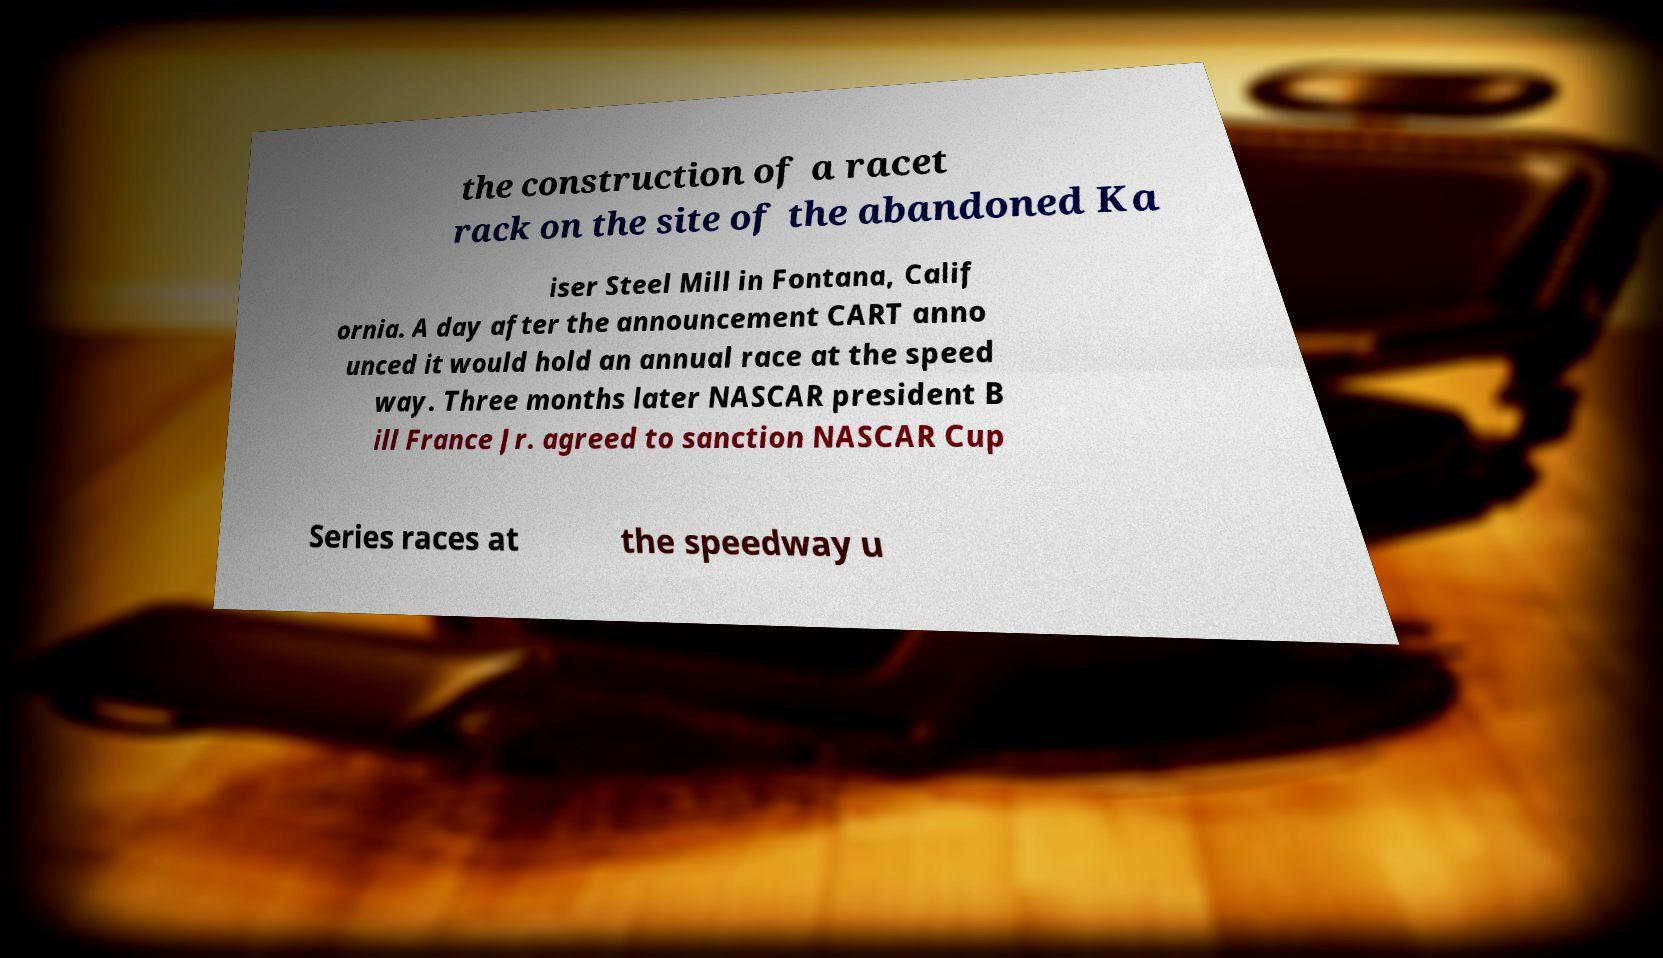For documentation purposes, I need the text within this image transcribed. Could you provide that? the construction of a racet rack on the site of the abandoned Ka iser Steel Mill in Fontana, Calif ornia. A day after the announcement CART anno unced it would hold an annual race at the speed way. Three months later NASCAR president B ill France Jr. agreed to sanction NASCAR Cup Series races at the speedway u 